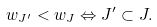<formula> <loc_0><loc_0><loc_500><loc_500>w _ { J ^ { \prime } } < w _ { J } \Leftrightarrow J ^ { \prime } \subset J .</formula> 